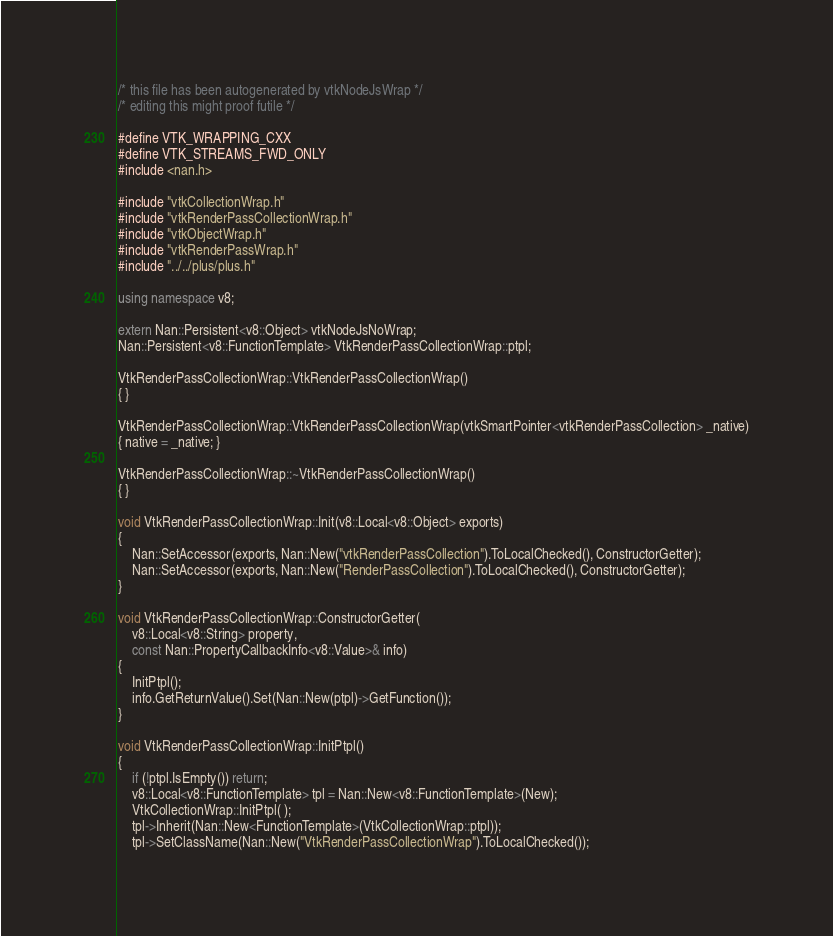Convert code to text. <code><loc_0><loc_0><loc_500><loc_500><_C++_>/* this file has been autogenerated by vtkNodeJsWrap */
/* editing this might proof futile */

#define VTK_WRAPPING_CXX
#define VTK_STREAMS_FWD_ONLY
#include <nan.h>

#include "vtkCollectionWrap.h"
#include "vtkRenderPassCollectionWrap.h"
#include "vtkObjectWrap.h"
#include "vtkRenderPassWrap.h"
#include "../../plus/plus.h"

using namespace v8;

extern Nan::Persistent<v8::Object> vtkNodeJsNoWrap;
Nan::Persistent<v8::FunctionTemplate> VtkRenderPassCollectionWrap::ptpl;

VtkRenderPassCollectionWrap::VtkRenderPassCollectionWrap()
{ }

VtkRenderPassCollectionWrap::VtkRenderPassCollectionWrap(vtkSmartPointer<vtkRenderPassCollection> _native)
{ native = _native; }

VtkRenderPassCollectionWrap::~VtkRenderPassCollectionWrap()
{ }

void VtkRenderPassCollectionWrap::Init(v8::Local<v8::Object> exports)
{
	Nan::SetAccessor(exports, Nan::New("vtkRenderPassCollection").ToLocalChecked(), ConstructorGetter);
	Nan::SetAccessor(exports, Nan::New("RenderPassCollection").ToLocalChecked(), ConstructorGetter);
}

void VtkRenderPassCollectionWrap::ConstructorGetter(
	v8::Local<v8::String> property,
	const Nan::PropertyCallbackInfo<v8::Value>& info)
{
	InitPtpl();
	info.GetReturnValue().Set(Nan::New(ptpl)->GetFunction());
}

void VtkRenderPassCollectionWrap::InitPtpl()
{
	if (!ptpl.IsEmpty()) return;
	v8::Local<v8::FunctionTemplate> tpl = Nan::New<v8::FunctionTemplate>(New);
	VtkCollectionWrap::InitPtpl( );
	tpl->Inherit(Nan::New<FunctionTemplate>(VtkCollectionWrap::ptpl));
	tpl->SetClassName(Nan::New("VtkRenderPassCollectionWrap").ToLocalChecked());</code> 